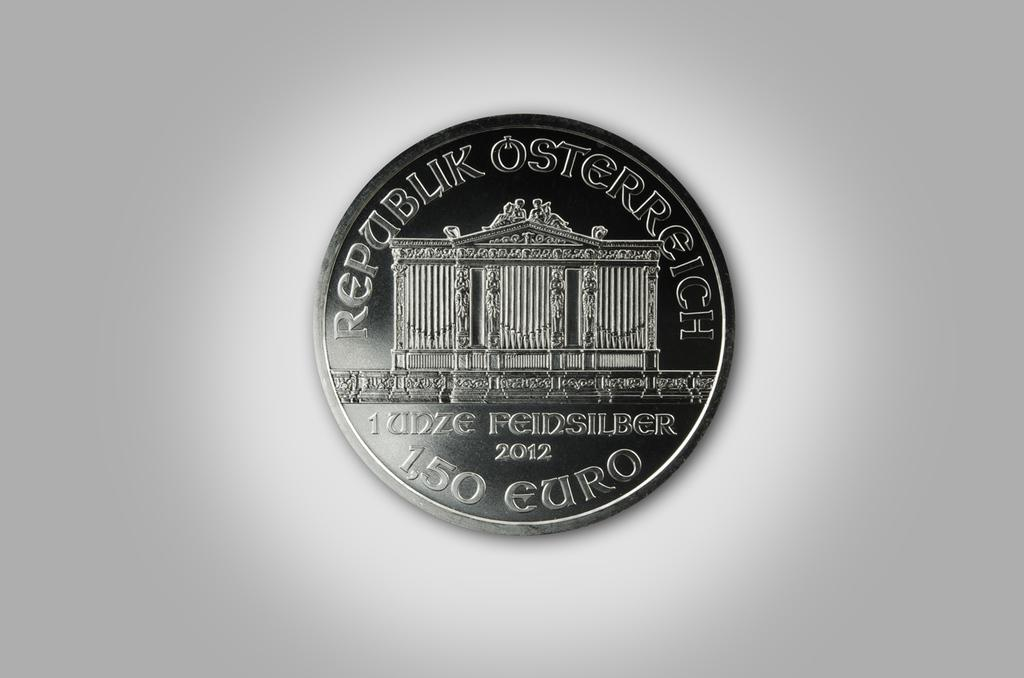<image>
Offer a succinct explanation of the picture presented. a 1,50 Euro coin from the Republik Osterreich 2012 